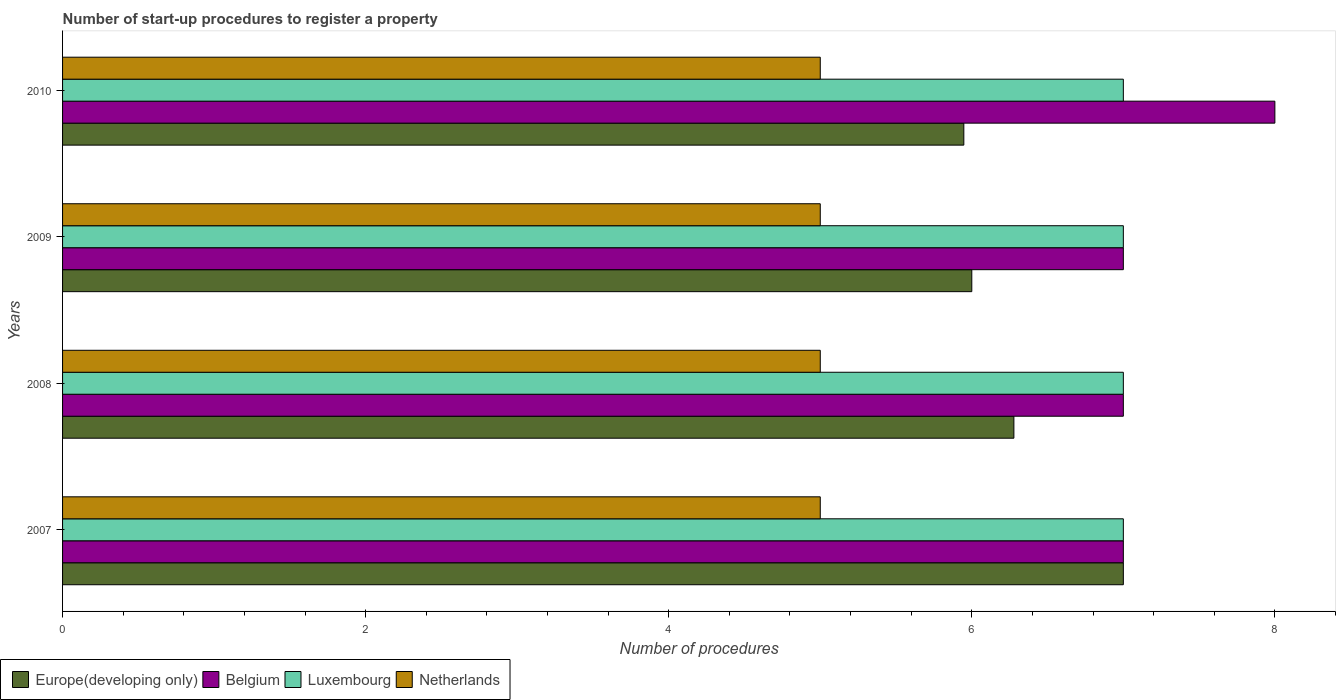How many different coloured bars are there?
Provide a succinct answer. 4. Are the number of bars per tick equal to the number of legend labels?
Ensure brevity in your answer.  Yes. How many bars are there on the 4th tick from the bottom?
Your answer should be compact. 4. What is the label of the 3rd group of bars from the top?
Give a very brief answer. 2008. In how many cases, is the number of bars for a given year not equal to the number of legend labels?
Make the answer very short. 0. What is the number of procedures required to register a property in Belgium in 2007?
Give a very brief answer. 7. Across all years, what is the maximum number of procedures required to register a property in Netherlands?
Offer a very short reply. 5. Across all years, what is the minimum number of procedures required to register a property in Netherlands?
Your answer should be very brief. 5. What is the total number of procedures required to register a property in Netherlands in the graph?
Your response must be concise. 20. What is the difference between the number of procedures required to register a property in Belgium in 2009 and that in 2010?
Your answer should be compact. -1. What is the difference between the number of procedures required to register a property in Luxembourg in 2010 and the number of procedures required to register a property in Netherlands in 2008?
Your answer should be compact. 2. What is the average number of procedures required to register a property in Europe(developing only) per year?
Make the answer very short. 6.31. In the year 2008, what is the difference between the number of procedures required to register a property in Europe(developing only) and number of procedures required to register a property in Netherlands?
Ensure brevity in your answer.  1.28. Is the number of procedures required to register a property in Belgium in 2007 less than that in 2008?
Offer a terse response. No. Is the difference between the number of procedures required to register a property in Europe(developing only) in 2007 and 2009 greater than the difference between the number of procedures required to register a property in Netherlands in 2007 and 2009?
Ensure brevity in your answer.  Yes. What is the difference between the highest and the second highest number of procedures required to register a property in Belgium?
Keep it short and to the point. 1. What is the difference between the highest and the lowest number of procedures required to register a property in Netherlands?
Keep it short and to the point. 0. Is the sum of the number of procedures required to register a property in Europe(developing only) in 2007 and 2010 greater than the maximum number of procedures required to register a property in Luxembourg across all years?
Offer a terse response. Yes. What does the 3rd bar from the top in 2010 represents?
Your answer should be very brief. Belgium. What does the 3rd bar from the bottom in 2007 represents?
Offer a terse response. Luxembourg. Is it the case that in every year, the sum of the number of procedures required to register a property in Europe(developing only) and number of procedures required to register a property in Netherlands is greater than the number of procedures required to register a property in Belgium?
Your answer should be compact. Yes. Are all the bars in the graph horizontal?
Keep it short and to the point. Yes. How many years are there in the graph?
Ensure brevity in your answer.  4. How are the legend labels stacked?
Your answer should be very brief. Horizontal. What is the title of the graph?
Ensure brevity in your answer.  Number of start-up procedures to register a property. What is the label or title of the X-axis?
Your answer should be compact. Number of procedures. What is the label or title of the Y-axis?
Ensure brevity in your answer.  Years. What is the Number of procedures of Europe(developing only) in 2007?
Provide a succinct answer. 7. What is the Number of procedures of Europe(developing only) in 2008?
Your answer should be very brief. 6.28. What is the Number of procedures of Belgium in 2008?
Provide a succinct answer. 7. What is the Number of procedures of Luxembourg in 2008?
Your response must be concise. 7. What is the Number of procedures in Netherlands in 2008?
Give a very brief answer. 5. What is the Number of procedures in Europe(developing only) in 2009?
Provide a short and direct response. 6. What is the Number of procedures of Belgium in 2009?
Give a very brief answer. 7. What is the Number of procedures in Netherlands in 2009?
Provide a succinct answer. 5. What is the Number of procedures in Europe(developing only) in 2010?
Make the answer very short. 5.95. What is the Number of procedures of Netherlands in 2010?
Offer a very short reply. 5. Across all years, what is the maximum Number of procedures in Belgium?
Make the answer very short. 8. Across all years, what is the maximum Number of procedures in Luxembourg?
Ensure brevity in your answer.  7. Across all years, what is the maximum Number of procedures in Netherlands?
Your answer should be compact. 5. Across all years, what is the minimum Number of procedures of Europe(developing only)?
Offer a very short reply. 5.95. What is the total Number of procedures in Europe(developing only) in the graph?
Offer a very short reply. 25.23. What is the total Number of procedures in Luxembourg in the graph?
Offer a terse response. 28. What is the total Number of procedures in Netherlands in the graph?
Your answer should be compact. 20. What is the difference between the Number of procedures of Europe(developing only) in 2007 and that in 2008?
Give a very brief answer. 0.72. What is the difference between the Number of procedures in Netherlands in 2007 and that in 2008?
Provide a short and direct response. 0. What is the difference between the Number of procedures in Belgium in 2007 and that in 2009?
Your answer should be very brief. 0. What is the difference between the Number of procedures of Europe(developing only) in 2007 and that in 2010?
Your answer should be very brief. 1.05. What is the difference between the Number of procedures in Europe(developing only) in 2008 and that in 2009?
Keep it short and to the point. 0.28. What is the difference between the Number of procedures in Luxembourg in 2008 and that in 2009?
Offer a terse response. 0. What is the difference between the Number of procedures of Europe(developing only) in 2008 and that in 2010?
Offer a very short reply. 0.33. What is the difference between the Number of procedures in Belgium in 2008 and that in 2010?
Make the answer very short. -1. What is the difference between the Number of procedures of Europe(developing only) in 2009 and that in 2010?
Make the answer very short. 0.05. What is the difference between the Number of procedures of Belgium in 2009 and that in 2010?
Give a very brief answer. -1. What is the difference between the Number of procedures in Luxembourg in 2009 and that in 2010?
Make the answer very short. 0. What is the difference between the Number of procedures of Netherlands in 2009 and that in 2010?
Make the answer very short. 0. What is the difference between the Number of procedures in Europe(developing only) in 2007 and the Number of procedures in Belgium in 2008?
Make the answer very short. 0. What is the difference between the Number of procedures of Europe(developing only) in 2007 and the Number of procedures of Luxembourg in 2008?
Your answer should be very brief. 0. What is the difference between the Number of procedures of Europe(developing only) in 2007 and the Number of procedures of Netherlands in 2008?
Your response must be concise. 2. What is the difference between the Number of procedures in Europe(developing only) in 2007 and the Number of procedures in Luxembourg in 2009?
Your answer should be very brief. 0. What is the difference between the Number of procedures of Belgium in 2007 and the Number of procedures of Luxembourg in 2009?
Offer a very short reply. 0. What is the difference between the Number of procedures of Europe(developing only) in 2007 and the Number of procedures of Belgium in 2010?
Give a very brief answer. -1. What is the difference between the Number of procedures of Europe(developing only) in 2007 and the Number of procedures of Luxembourg in 2010?
Ensure brevity in your answer.  0. What is the difference between the Number of procedures of Europe(developing only) in 2007 and the Number of procedures of Netherlands in 2010?
Provide a succinct answer. 2. What is the difference between the Number of procedures in Belgium in 2007 and the Number of procedures in Luxembourg in 2010?
Provide a short and direct response. 0. What is the difference between the Number of procedures in Belgium in 2007 and the Number of procedures in Netherlands in 2010?
Provide a succinct answer. 2. What is the difference between the Number of procedures in Europe(developing only) in 2008 and the Number of procedures in Belgium in 2009?
Your answer should be very brief. -0.72. What is the difference between the Number of procedures of Europe(developing only) in 2008 and the Number of procedures of Luxembourg in 2009?
Your answer should be compact. -0.72. What is the difference between the Number of procedures in Europe(developing only) in 2008 and the Number of procedures in Netherlands in 2009?
Give a very brief answer. 1.28. What is the difference between the Number of procedures in Luxembourg in 2008 and the Number of procedures in Netherlands in 2009?
Offer a terse response. 2. What is the difference between the Number of procedures of Europe(developing only) in 2008 and the Number of procedures of Belgium in 2010?
Ensure brevity in your answer.  -1.72. What is the difference between the Number of procedures in Europe(developing only) in 2008 and the Number of procedures in Luxembourg in 2010?
Make the answer very short. -0.72. What is the difference between the Number of procedures in Europe(developing only) in 2008 and the Number of procedures in Netherlands in 2010?
Offer a terse response. 1.28. What is the difference between the Number of procedures of Luxembourg in 2008 and the Number of procedures of Netherlands in 2010?
Your response must be concise. 2. What is the average Number of procedures of Europe(developing only) per year?
Make the answer very short. 6.31. What is the average Number of procedures of Belgium per year?
Ensure brevity in your answer.  7.25. What is the average Number of procedures of Luxembourg per year?
Ensure brevity in your answer.  7. In the year 2007, what is the difference between the Number of procedures in Europe(developing only) and Number of procedures in Netherlands?
Your response must be concise. 2. In the year 2007, what is the difference between the Number of procedures in Belgium and Number of procedures in Luxembourg?
Give a very brief answer. 0. In the year 2007, what is the difference between the Number of procedures in Belgium and Number of procedures in Netherlands?
Offer a very short reply. 2. In the year 2007, what is the difference between the Number of procedures of Luxembourg and Number of procedures of Netherlands?
Offer a very short reply. 2. In the year 2008, what is the difference between the Number of procedures in Europe(developing only) and Number of procedures in Belgium?
Offer a terse response. -0.72. In the year 2008, what is the difference between the Number of procedures in Europe(developing only) and Number of procedures in Luxembourg?
Make the answer very short. -0.72. In the year 2008, what is the difference between the Number of procedures in Europe(developing only) and Number of procedures in Netherlands?
Ensure brevity in your answer.  1.28. In the year 2008, what is the difference between the Number of procedures in Luxembourg and Number of procedures in Netherlands?
Your answer should be very brief. 2. In the year 2009, what is the difference between the Number of procedures in Europe(developing only) and Number of procedures in Netherlands?
Keep it short and to the point. 1. In the year 2009, what is the difference between the Number of procedures in Belgium and Number of procedures in Luxembourg?
Make the answer very short. 0. In the year 2009, what is the difference between the Number of procedures of Belgium and Number of procedures of Netherlands?
Offer a terse response. 2. In the year 2009, what is the difference between the Number of procedures in Luxembourg and Number of procedures in Netherlands?
Offer a very short reply. 2. In the year 2010, what is the difference between the Number of procedures of Europe(developing only) and Number of procedures of Belgium?
Keep it short and to the point. -2.05. In the year 2010, what is the difference between the Number of procedures of Europe(developing only) and Number of procedures of Luxembourg?
Offer a terse response. -1.05. In the year 2010, what is the difference between the Number of procedures of Europe(developing only) and Number of procedures of Netherlands?
Offer a terse response. 0.95. In the year 2010, what is the difference between the Number of procedures of Belgium and Number of procedures of Netherlands?
Your answer should be compact. 3. What is the ratio of the Number of procedures in Europe(developing only) in 2007 to that in 2008?
Offer a very short reply. 1.11. What is the ratio of the Number of procedures in Luxembourg in 2007 to that in 2008?
Your response must be concise. 1. What is the ratio of the Number of procedures of Europe(developing only) in 2007 to that in 2009?
Keep it short and to the point. 1.17. What is the ratio of the Number of procedures in Luxembourg in 2007 to that in 2009?
Offer a terse response. 1. What is the ratio of the Number of procedures in Europe(developing only) in 2007 to that in 2010?
Offer a very short reply. 1.18. What is the ratio of the Number of procedures in Belgium in 2007 to that in 2010?
Provide a short and direct response. 0.88. What is the ratio of the Number of procedures in Europe(developing only) in 2008 to that in 2009?
Offer a terse response. 1.05. What is the ratio of the Number of procedures of Belgium in 2008 to that in 2009?
Offer a very short reply. 1. What is the ratio of the Number of procedures in Europe(developing only) in 2008 to that in 2010?
Give a very brief answer. 1.06. What is the ratio of the Number of procedures of Belgium in 2008 to that in 2010?
Keep it short and to the point. 0.88. What is the ratio of the Number of procedures of Netherlands in 2008 to that in 2010?
Ensure brevity in your answer.  1. What is the ratio of the Number of procedures in Europe(developing only) in 2009 to that in 2010?
Your response must be concise. 1.01. What is the ratio of the Number of procedures of Luxembourg in 2009 to that in 2010?
Your response must be concise. 1. What is the difference between the highest and the second highest Number of procedures in Europe(developing only)?
Your answer should be very brief. 0.72. What is the difference between the highest and the second highest Number of procedures in Netherlands?
Your response must be concise. 0. What is the difference between the highest and the lowest Number of procedures of Europe(developing only)?
Ensure brevity in your answer.  1.05. What is the difference between the highest and the lowest Number of procedures in Belgium?
Offer a very short reply. 1. What is the difference between the highest and the lowest Number of procedures in Netherlands?
Offer a very short reply. 0. 